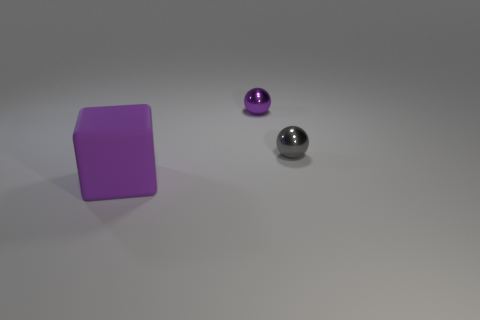There is a purple metal sphere left of the shiny thing that is in front of the tiny purple object; what size is it?
Make the answer very short. Small. Is the object that is in front of the small gray metallic ball made of the same material as the small gray thing?
Your answer should be very brief. No. The purple object on the right side of the cube has what shape?
Keep it short and to the point. Sphere. How many other purple blocks have the same size as the rubber block?
Your answer should be very brief. 0. What size is the purple rubber block?
Offer a terse response. Large. How many purple things are on the left side of the purple sphere?
Offer a terse response. 1. Is the number of big things that are behind the rubber block less than the number of small metal things that are behind the tiny purple thing?
Your response must be concise. No. Are there more tiny blue matte blocks than large purple rubber cubes?
Ensure brevity in your answer.  No. What is the large block made of?
Make the answer very short. Rubber. There is a small metal object that is to the left of the gray metal ball; what color is it?
Make the answer very short. Purple. 